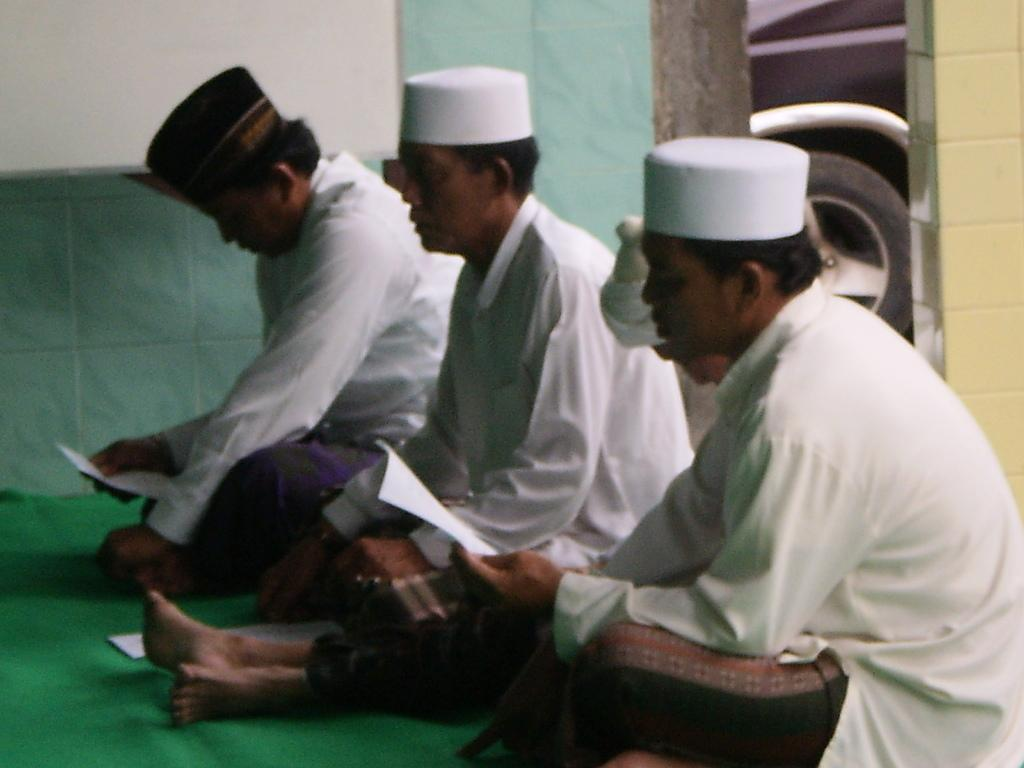How many people are in the image? There are three persons in the image. What are the persons doing in the image? The persons are sitting on the floor. What are the persons wearing on their heads? The persons are wearing caps. What are two of the persons holding in the image? Two of the persons are holding papers. What can be seen in the background of the image? There is a wall in the background of the image. What type of pain can be seen on the faces of the persons in the image? There is no indication of pain on the faces of the persons in the image. Can you tell me where the vase is located in the image? There is no vase present in the image. Is there a basketball visible in the image? There is no basketball present in the image. 